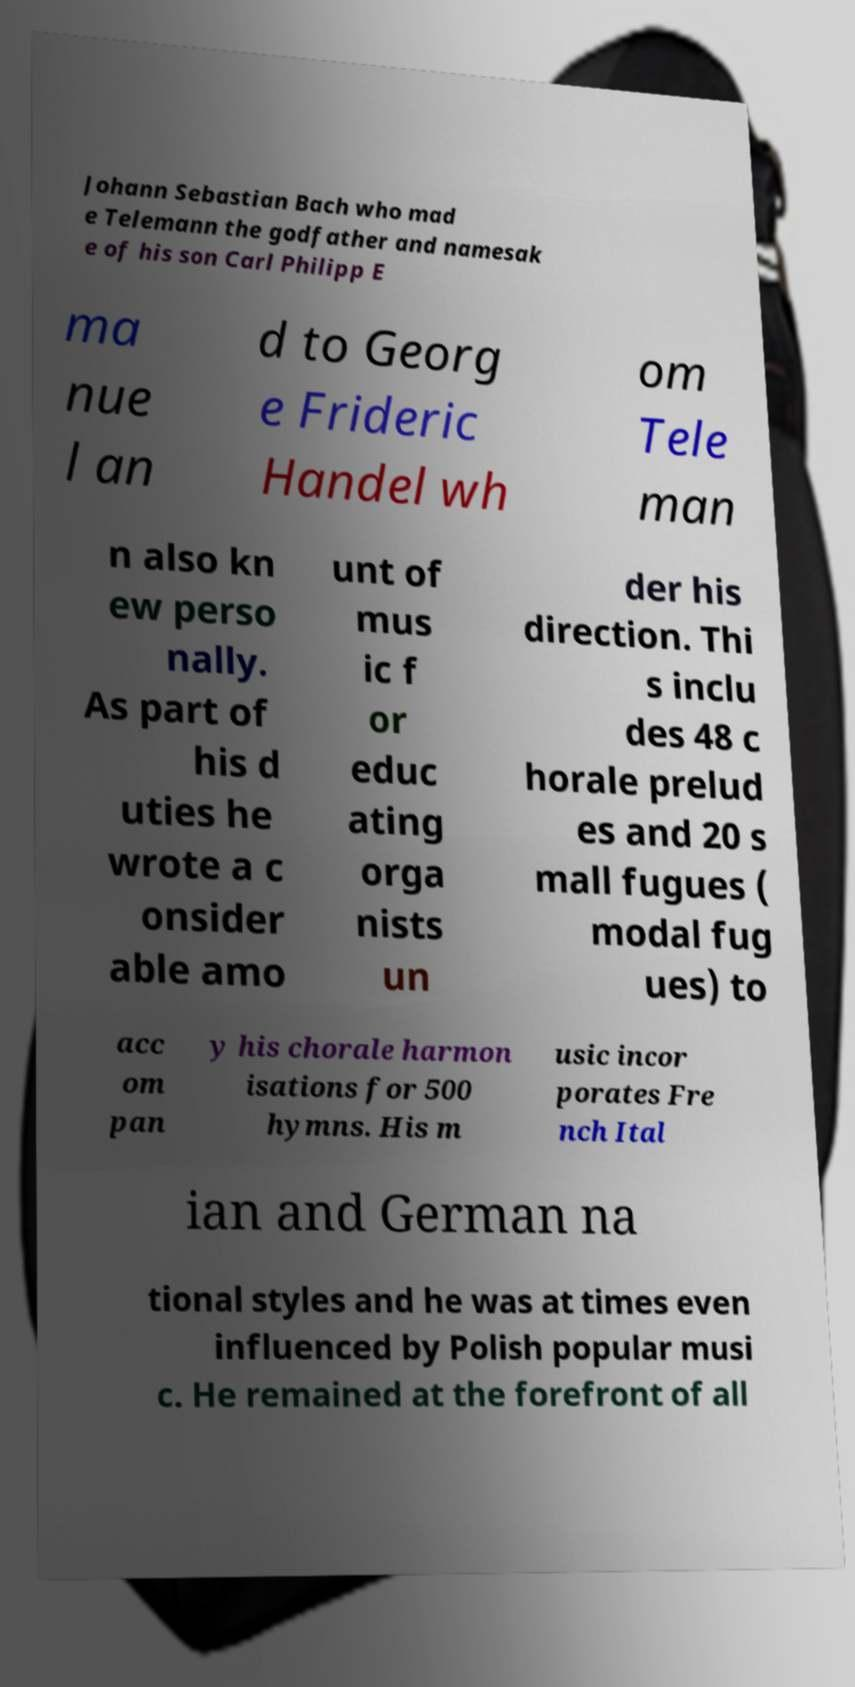Please read and relay the text visible in this image. What does it say? Johann Sebastian Bach who mad e Telemann the godfather and namesak e of his son Carl Philipp E ma nue l an d to Georg e Frideric Handel wh om Tele man n also kn ew perso nally. As part of his d uties he wrote a c onsider able amo unt of mus ic f or educ ating orga nists un der his direction. Thi s inclu des 48 c horale prelud es and 20 s mall fugues ( modal fug ues) to acc om pan y his chorale harmon isations for 500 hymns. His m usic incor porates Fre nch Ital ian and German na tional styles and he was at times even influenced by Polish popular musi c. He remained at the forefront of all 